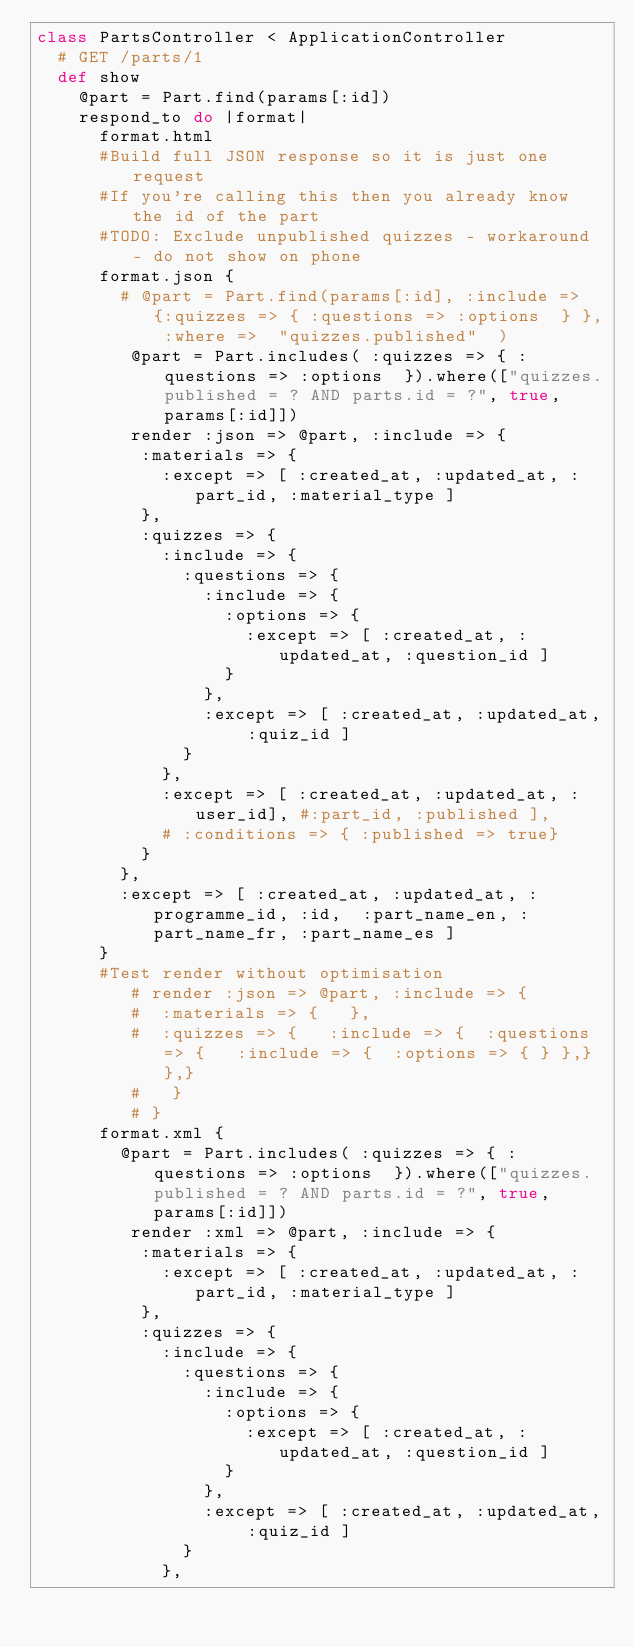<code> <loc_0><loc_0><loc_500><loc_500><_Ruby_>class PartsController < ApplicationController
  # GET /parts/1
  def show
    @part = Part.find(params[:id])
    respond_to do |format|
      format.html
      #Build full JSON response so it is just one request
      #If you're calling this then you already know the id of the part
      #TODO: Exclude unpublished quizzes - workaround - do not show on phone
      format.json {
        # @part = Part.find(params[:id], :include => {:quizzes => { :questions => :options  } }, :where =>  "quizzes.published"  )
         @part = Part.includes( :quizzes => { :questions => :options  }).where(["quizzes.published = ? AND parts.id = ?", true, params[:id]])
         render :json => @part, :include => {
          :materials => {
            :except => [ :created_at, :updated_at, :part_id, :material_type ]
          },
          :quizzes => { 
            :include => {
              :questions => {
                :include => { 
                  :options => { 
                    :except => [ :created_at, :updated_at, :question_id ] 
                  }
                },
                :except => [ :created_at, :updated_at, :quiz_id ]
              }
            },
            :except => [ :created_at, :updated_at, :user_id], #:part_id, :published ],
            # :conditions => { :published => true}
          }
        },
        :except => [ :created_at, :updated_at, :programme_id, :id,  :part_name_en, :part_name_fr, :part_name_es ] 
      }
      #Test render without optimisation
         # render :json => @part, :include => {
         #  :materials => {   },
         #  :quizzes => {   :include => {  :questions => {   :include => {  :options => { } },} },}
         #   }
         # }
      format.xml {
        @part = Part.includes( :quizzes => { :questions => :options  }).where(["quizzes.published = ? AND parts.id = ?", true, params[:id]])
         render :xml => @part, :include => {
          :materials => {
            :except => [ :created_at, :updated_at, :part_id, :material_type ]
          },
          :quizzes => { 
            :include => {
              :questions => {
                :include => { 
                  :options => { 
                    :except => [ :created_at, :updated_at, :question_id ] 
                  }
                },
                :except => [ :created_at, :updated_at, :quiz_id ]
              }
            },</code> 